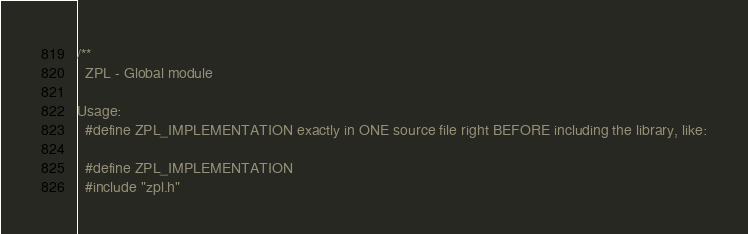Convert code to text. <code><loc_0><loc_0><loc_500><loc_500><_C_>/**
  ZPL - Global module

Usage:
  #define ZPL_IMPLEMENTATION exactly in ONE source file right BEFORE including the library, like:

  #define ZPL_IMPLEMENTATION
  #include "zpl.h"
</code> 